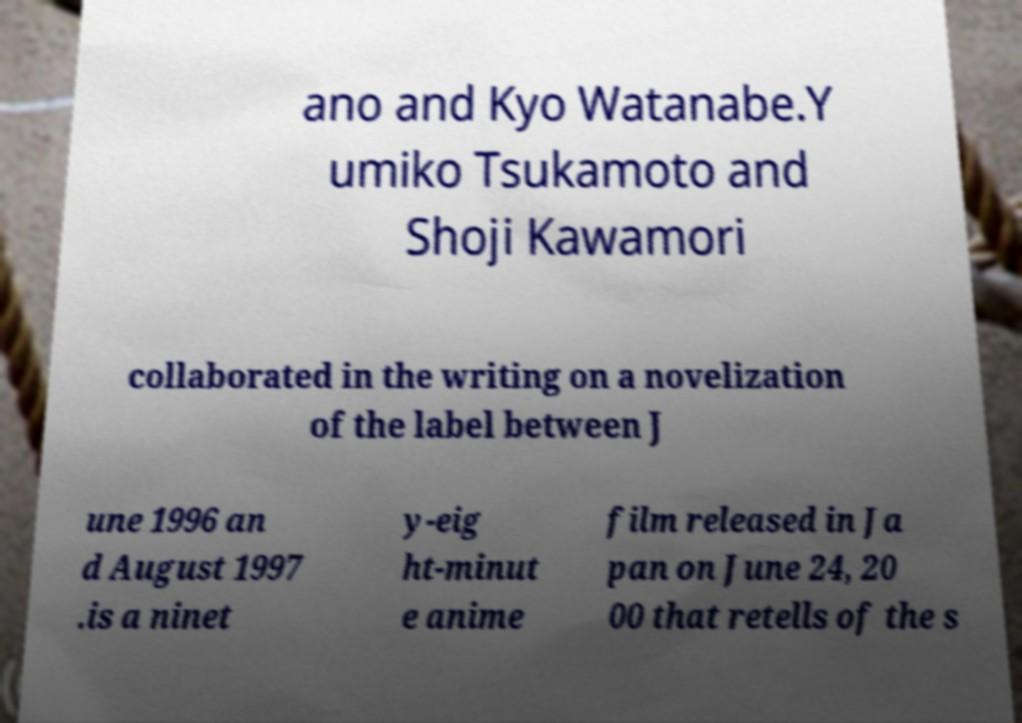There's text embedded in this image that I need extracted. Can you transcribe it verbatim? ano and Kyo Watanabe.Y umiko Tsukamoto and Shoji Kawamori collaborated in the writing on a novelization of the label between J une 1996 an d August 1997 .is a ninet y-eig ht-minut e anime film released in Ja pan on June 24, 20 00 that retells of the s 